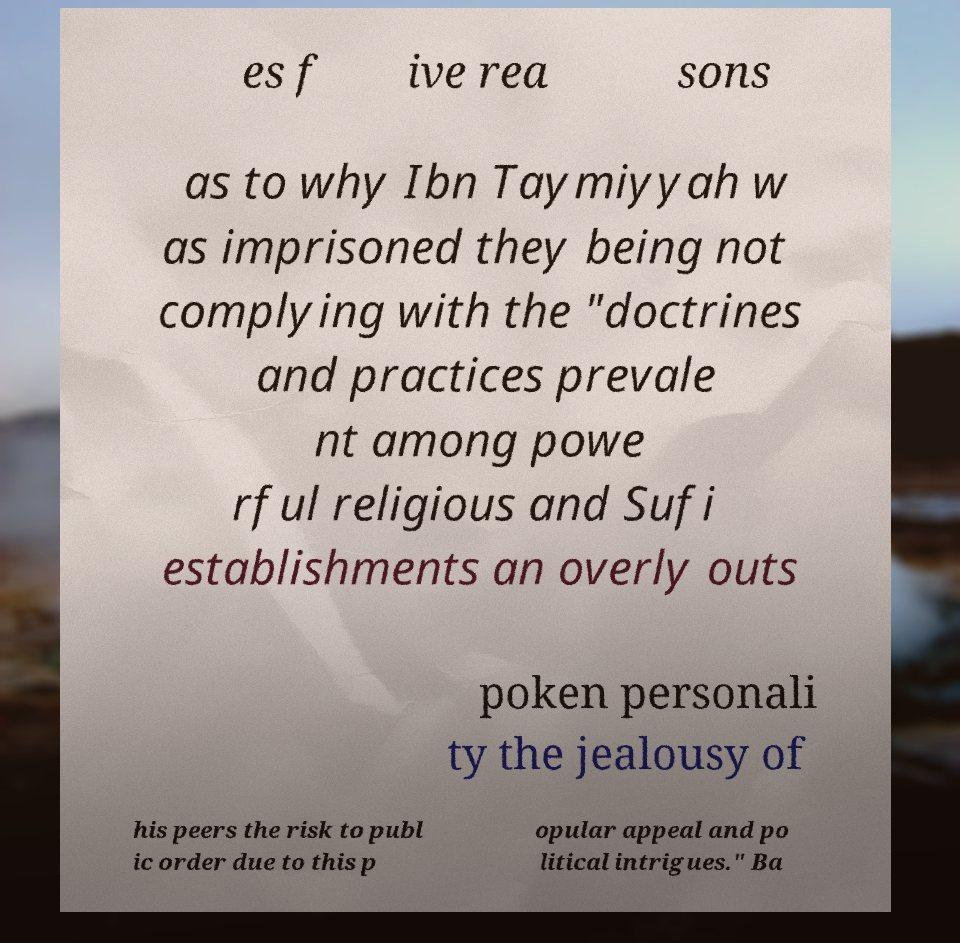Can you accurately transcribe the text from the provided image for me? es f ive rea sons as to why Ibn Taymiyyah w as imprisoned they being not complying with the "doctrines and practices prevale nt among powe rful religious and Sufi establishments an overly outs poken personali ty the jealousy of his peers the risk to publ ic order due to this p opular appeal and po litical intrigues." Ba 